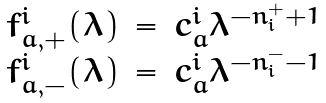Convert formula to latex. <formula><loc_0><loc_0><loc_500><loc_500>\begin{array} { r c l } f ^ { i } _ { a , + } ( \lambda ) & = & c ^ { i } _ { a } \lambda ^ { - n ^ { + } _ { i } + 1 } \\ f ^ { i } _ { a , - } ( \lambda ) & = & c ^ { i } _ { a } \lambda ^ { - n ^ { - } _ { i } - 1 } \\ \end{array}</formula> 